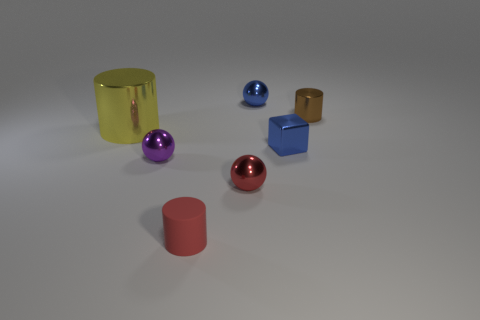Add 1 large green cylinders. How many objects exist? 8 Subtract all purple balls. How many balls are left? 2 Subtract all blocks. How many objects are left? 6 Subtract all cyan balls. How many yellow cylinders are left? 1 Subtract all small red cylinders. Subtract all big gray metallic cylinders. How many objects are left? 6 Add 6 small red objects. How many small red objects are left? 8 Add 5 green cylinders. How many green cylinders exist? 5 Subtract all brown cylinders. How many cylinders are left? 2 Subtract 0 cyan spheres. How many objects are left? 7 Subtract 2 spheres. How many spheres are left? 1 